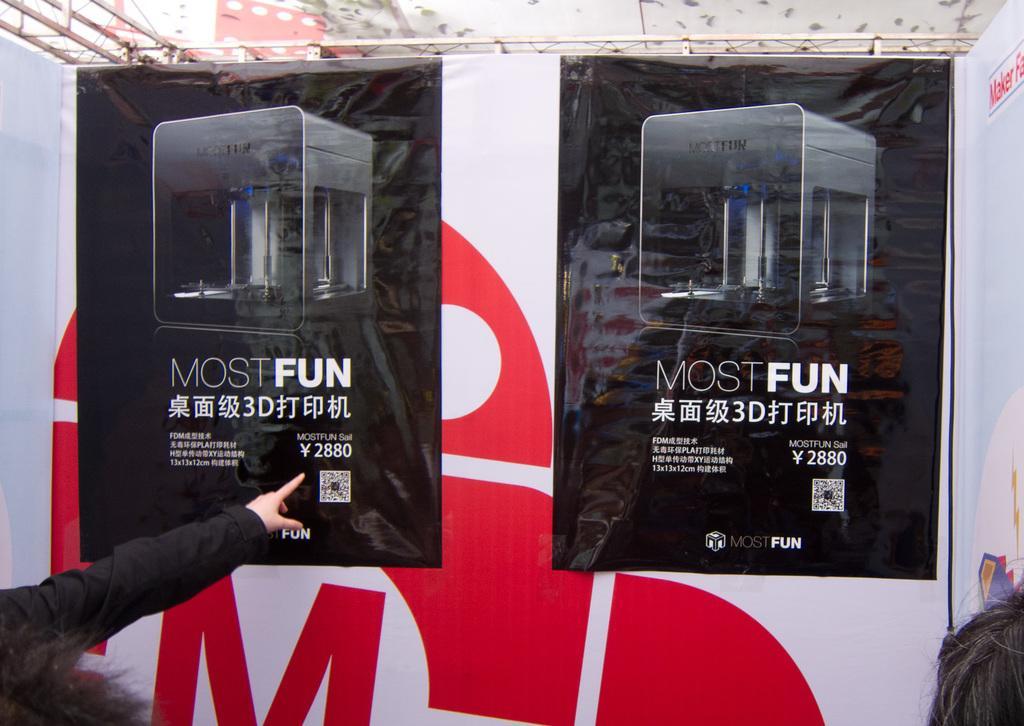Can you describe this image briefly? In this image I can see few black colour posters and on these posters I can see something is written. Here I can see a hand of a person and I can also see white colour boards in background. 